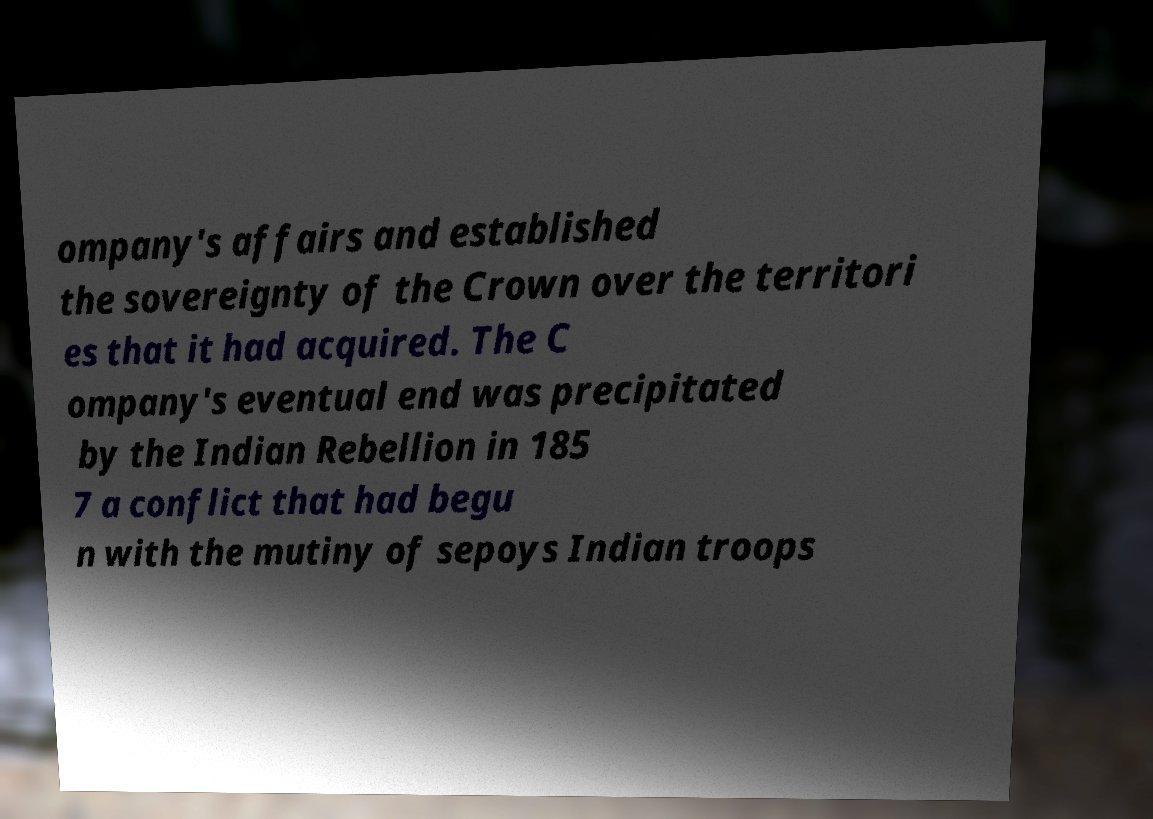Please identify and transcribe the text found in this image. ompany's affairs and established the sovereignty of the Crown over the territori es that it had acquired. The C ompany's eventual end was precipitated by the Indian Rebellion in 185 7 a conflict that had begu n with the mutiny of sepoys Indian troops 